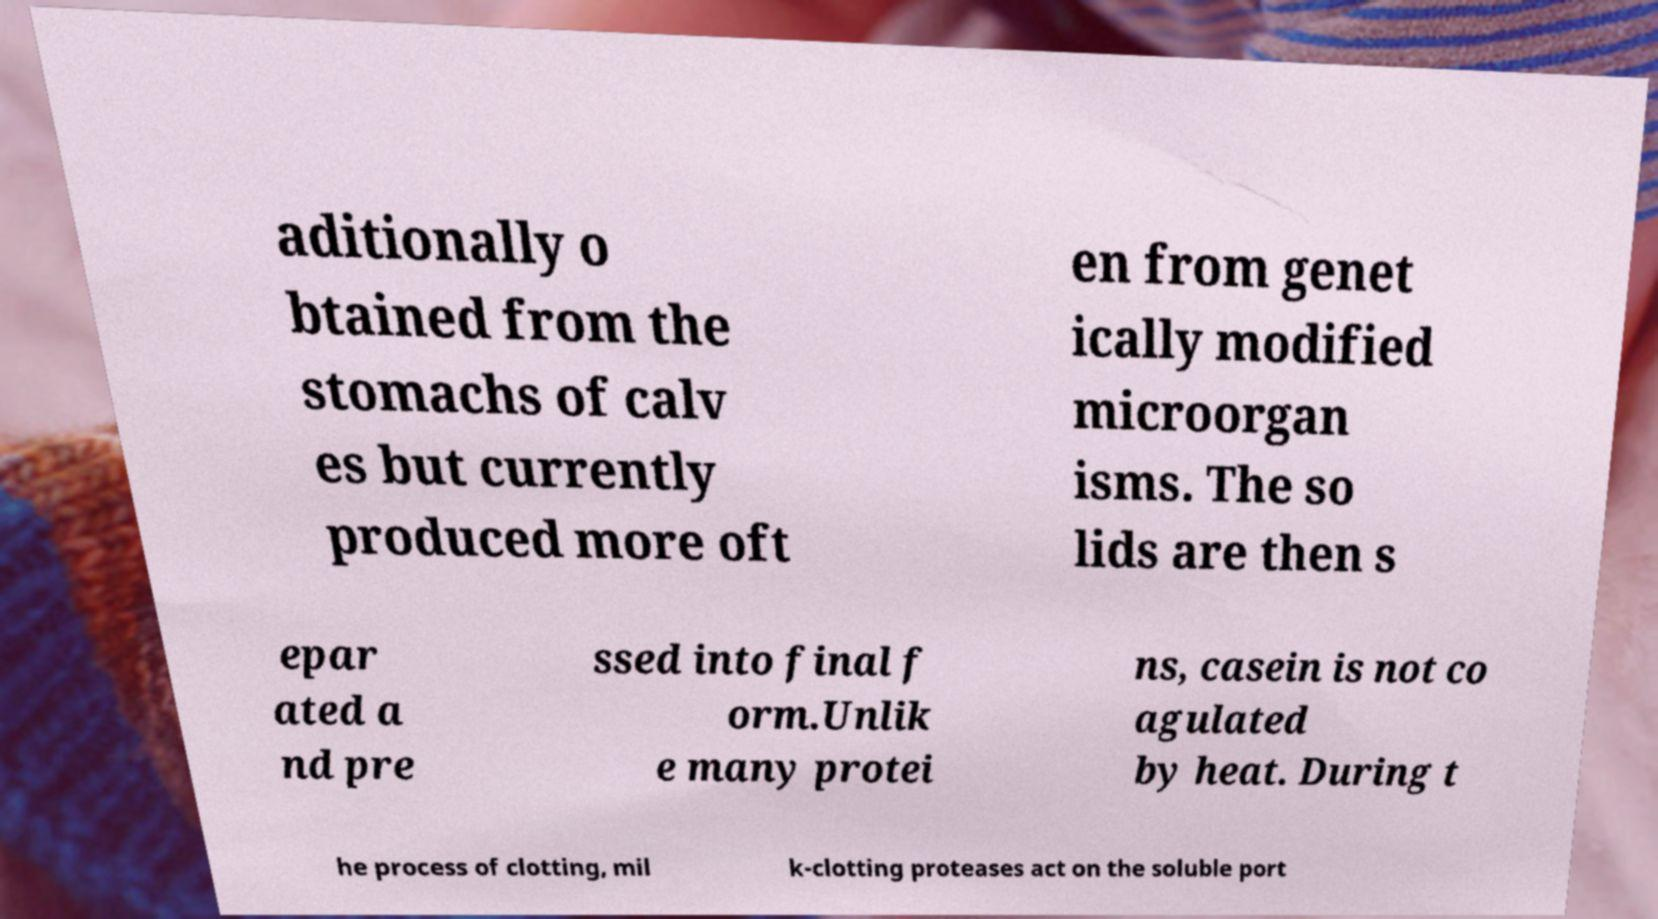Please read and relay the text visible in this image. What does it say? aditionally o btained from the stomachs of calv es but currently produced more oft en from genet ically modified microorgan isms. The so lids are then s epar ated a nd pre ssed into final f orm.Unlik e many protei ns, casein is not co agulated by heat. During t he process of clotting, mil k-clotting proteases act on the soluble port 